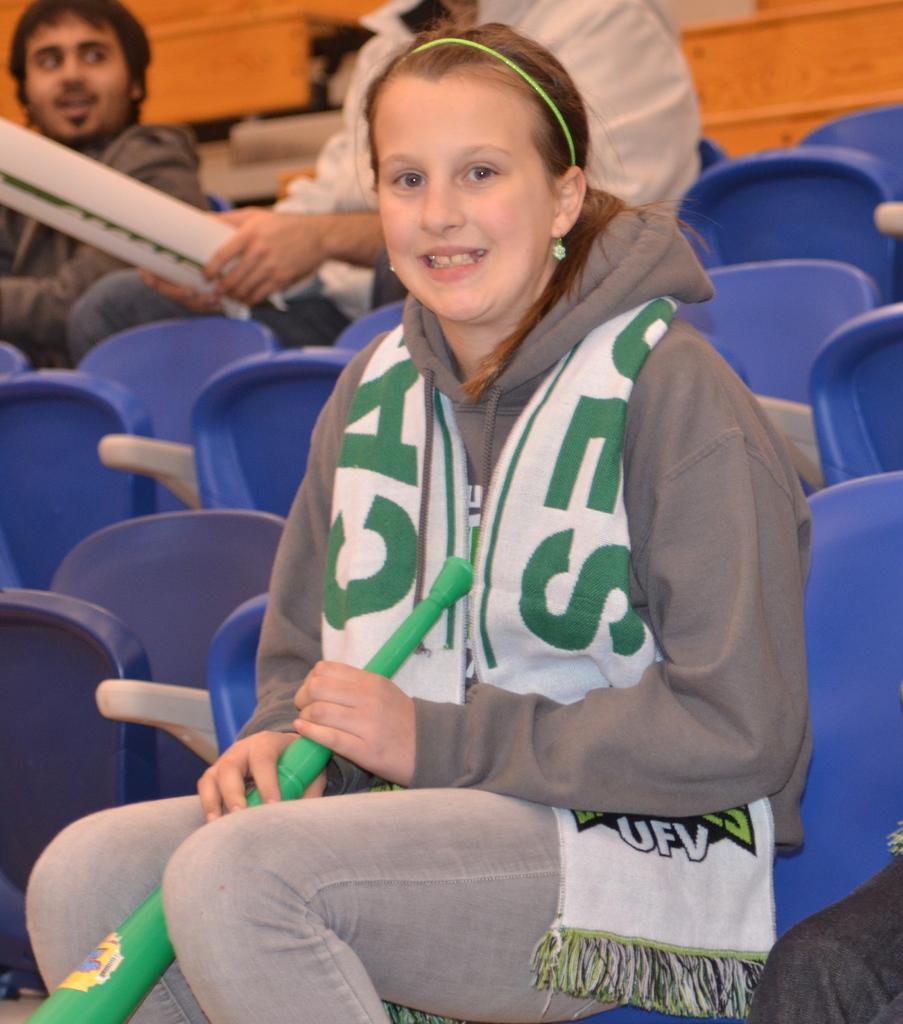What are the initials of the girl's school?
Offer a terse response. Ufv. What is the last letter in green on the girl's scarf?
Provide a short and direct response. S. 